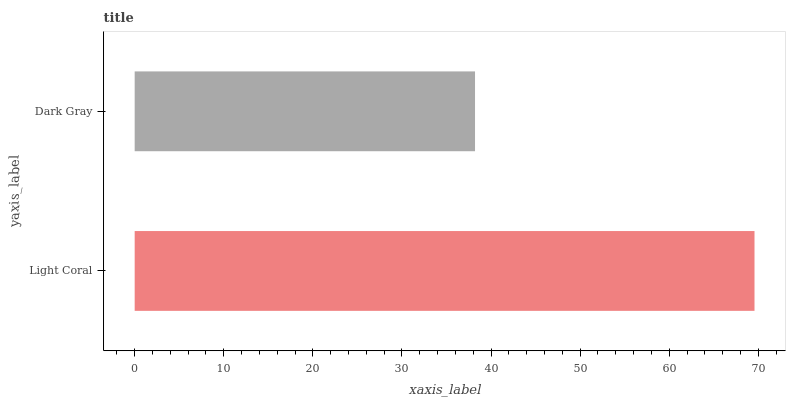Is Dark Gray the minimum?
Answer yes or no. Yes. Is Light Coral the maximum?
Answer yes or no. Yes. Is Dark Gray the maximum?
Answer yes or no. No. Is Light Coral greater than Dark Gray?
Answer yes or no. Yes. Is Dark Gray less than Light Coral?
Answer yes or no. Yes. Is Dark Gray greater than Light Coral?
Answer yes or no. No. Is Light Coral less than Dark Gray?
Answer yes or no. No. Is Light Coral the high median?
Answer yes or no. Yes. Is Dark Gray the low median?
Answer yes or no. Yes. Is Dark Gray the high median?
Answer yes or no. No. Is Light Coral the low median?
Answer yes or no. No. 